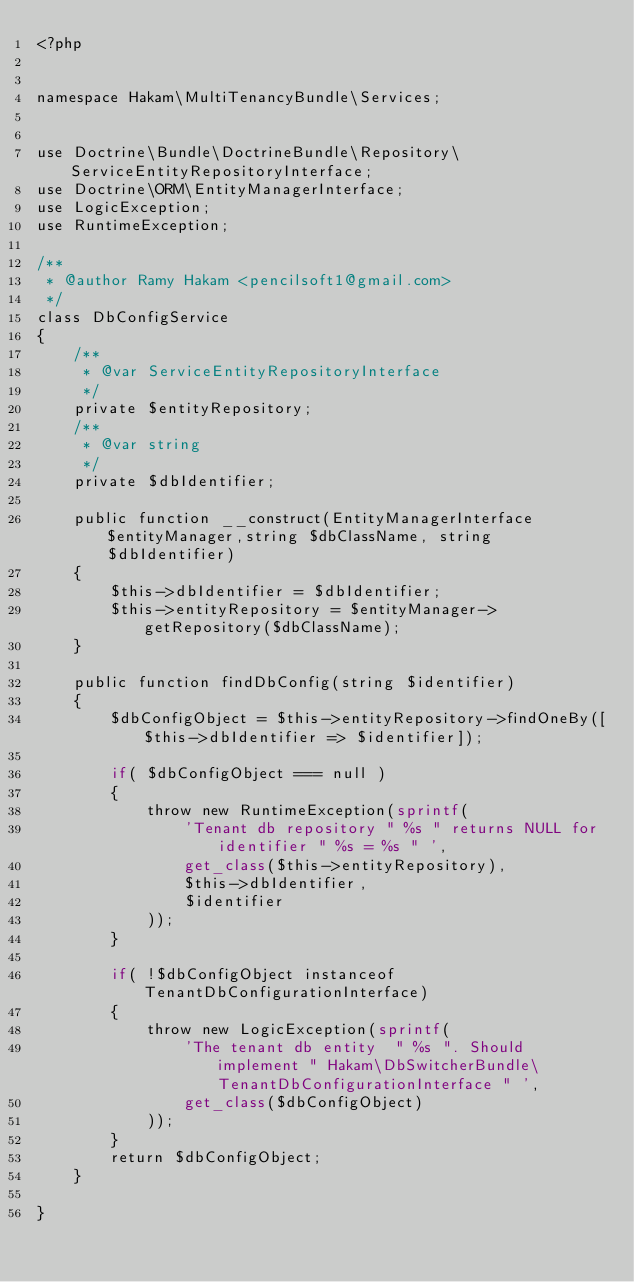Convert code to text. <code><loc_0><loc_0><loc_500><loc_500><_PHP_><?php


namespace Hakam\MultiTenancyBundle\Services;


use Doctrine\Bundle\DoctrineBundle\Repository\ServiceEntityRepositoryInterface;
use Doctrine\ORM\EntityManagerInterface;
use LogicException;
use RuntimeException;

/**
 * @author Ramy Hakam <pencilsoft1@gmail.com>
 */
class DbConfigService
{
    /**
     * @var ServiceEntityRepositoryInterface
     */
    private $entityRepository;
    /**
     * @var string
     */
    private $dbIdentifier;

    public function __construct(EntityManagerInterface $entityManager,string $dbClassName, string $dbIdentifier)
    {
        $this->dbIdentifier = $dbIdentifier;
        $this->entityRepository = $entityManager->getRepository($dbClassName);
    }

    public function findDbConfig(string $identifier)
    {
        $dbConfigObject = $this->entityRepository->findOneBy([$this->dbIdentifier => $identifier]);

        if( $dbConfigObject === null )
        {
            throw new RuntimeException(sprintf(
                'Tenant db repository " %s " returns NULL for identifier " %s = %s " ',
                get_class($this->entityRepository),
                $this->dbIdentifier,
                $identifier
            ));
        }

        if( !$dbConfigObject instanceof TenantDbConfigurationInterface)
        {
            throw new LogicException(sprintf(
                'The tenant db entity  " %s ". Should implement " Hakam\DbSwitcherBundle\TenantDbConfigurationInterface " ',
                get_class($dbConfigObject)
            ));
        }
        return $dbConfigObject;
    }

}</code> 